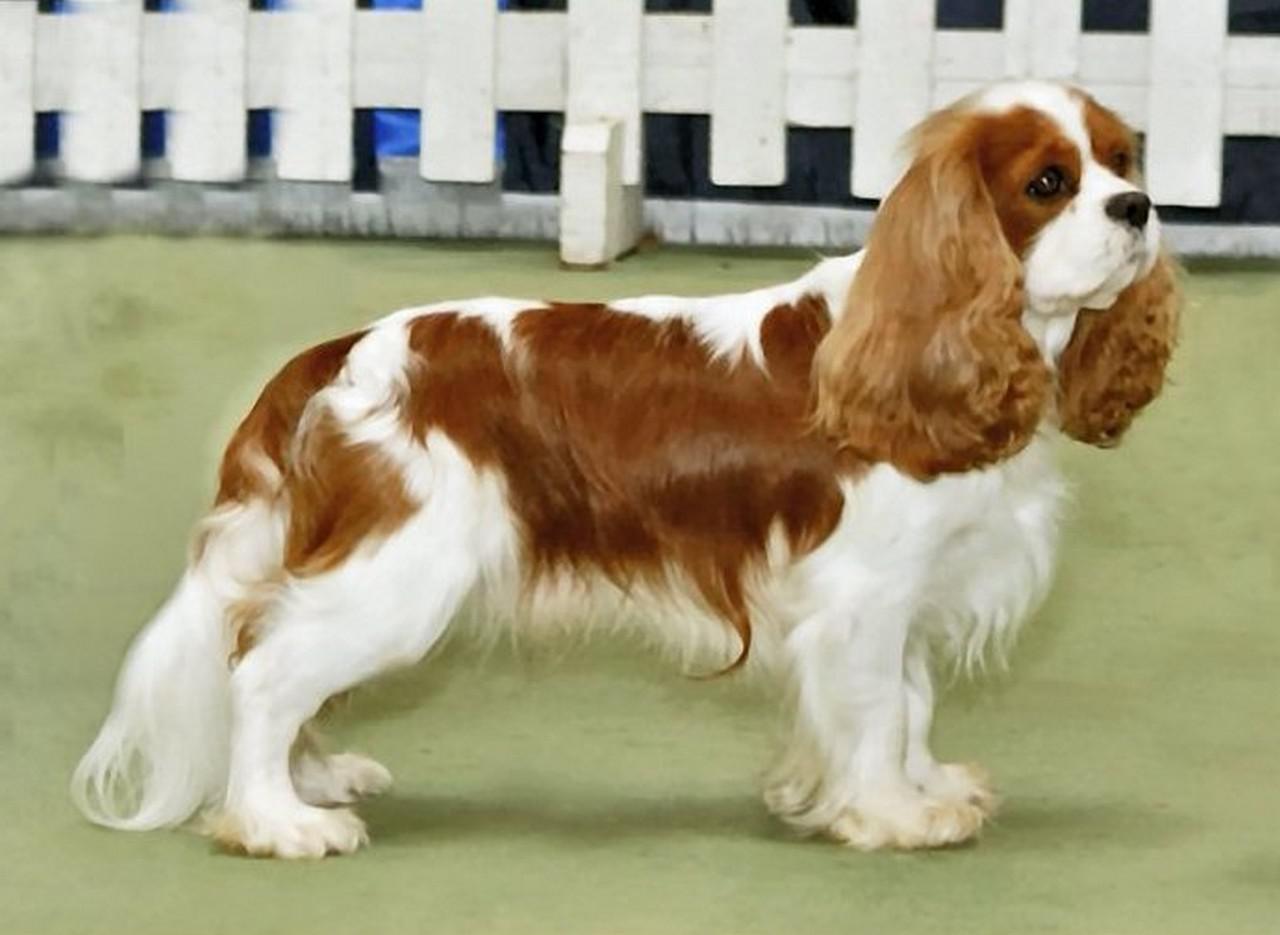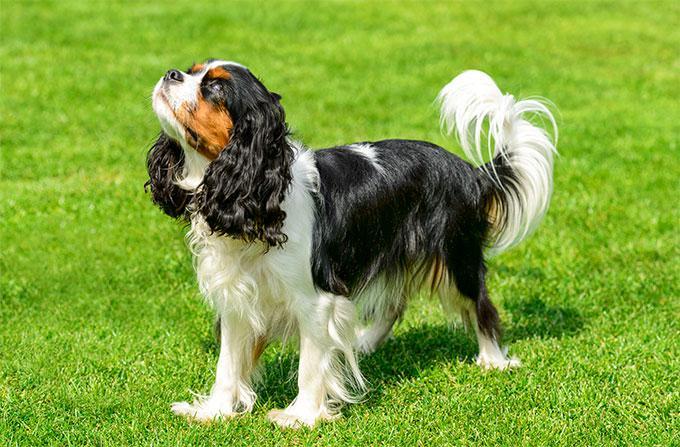The first image is the image on the left, the second image is the image on the right. Considering the images on both sides, is "Each image contains exactly one spaniel, and only the dog on the right is posed on real grass." valid? Answer yes or no. Yes. The first image is the image on the left, the second image is the image on the right. For the images shown, is this caption "2 dogs exactly can be seen and they are both facing the same way." true? Answer yes or no. No. 